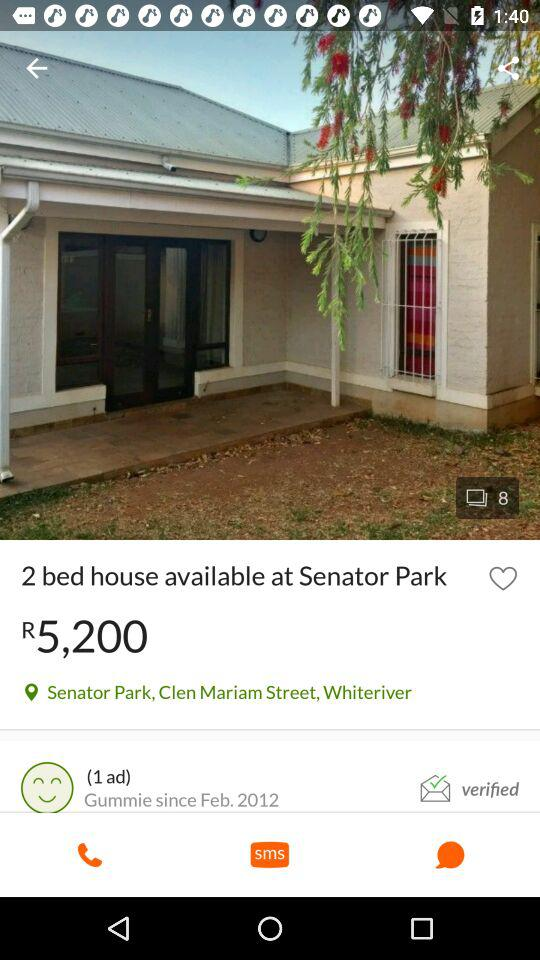What is the location? The location is Senator Park, Clen Mariam Street, Whiteriver. 